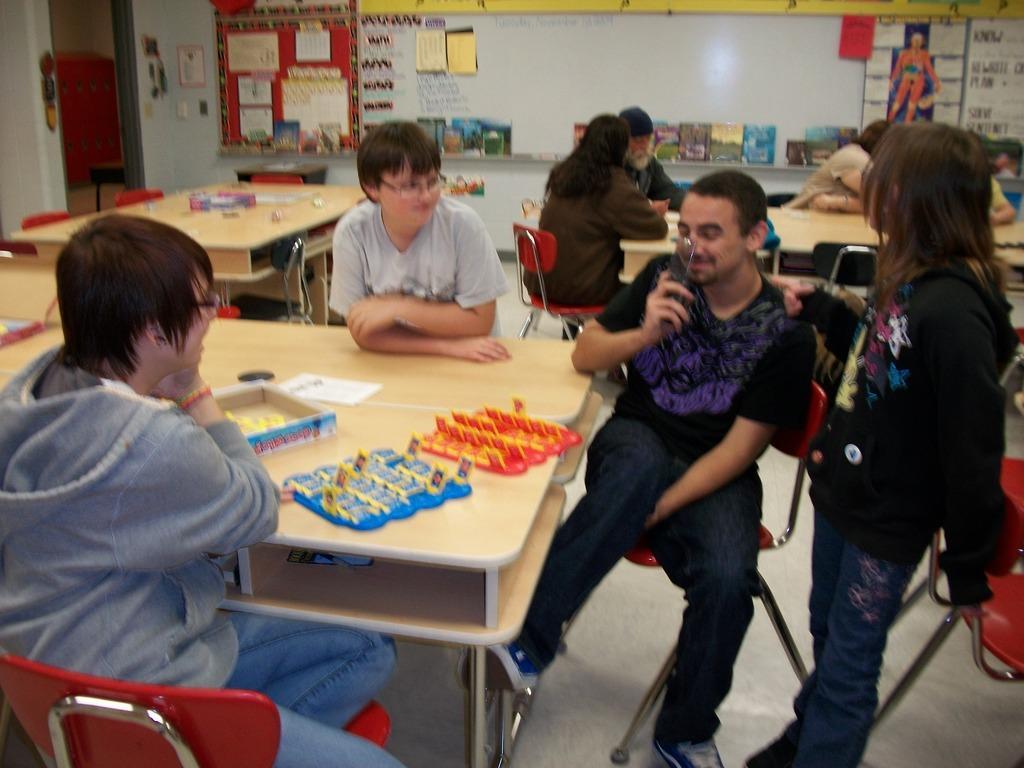In one or two sentences, can you explain what this image depicts? In this image we can see the persons sitting on the chairs which are on the floor and we can also see some objects and a box, paper on the wooden table. There is a girl standing. In the background we can also see the tables, chairs, people and also the papers with text attached to the wall. We can also see some books on the counter. Posters are also visible in this image. 